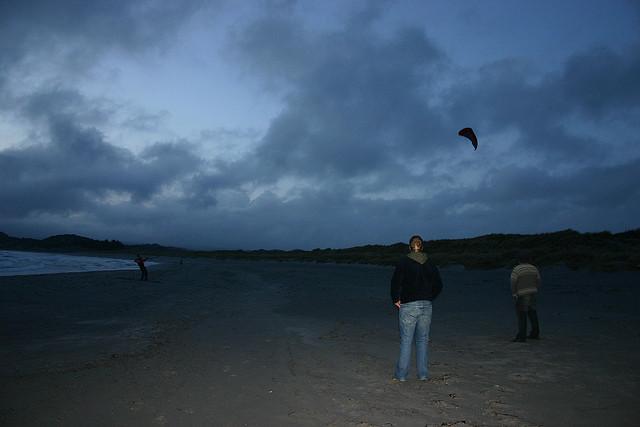How many people are in the photo?
Short answer required. 3. What time of day is it?
Quick response, please. Night. What activity is the man doing in the picture?
Quick response, please. Flying kite. 